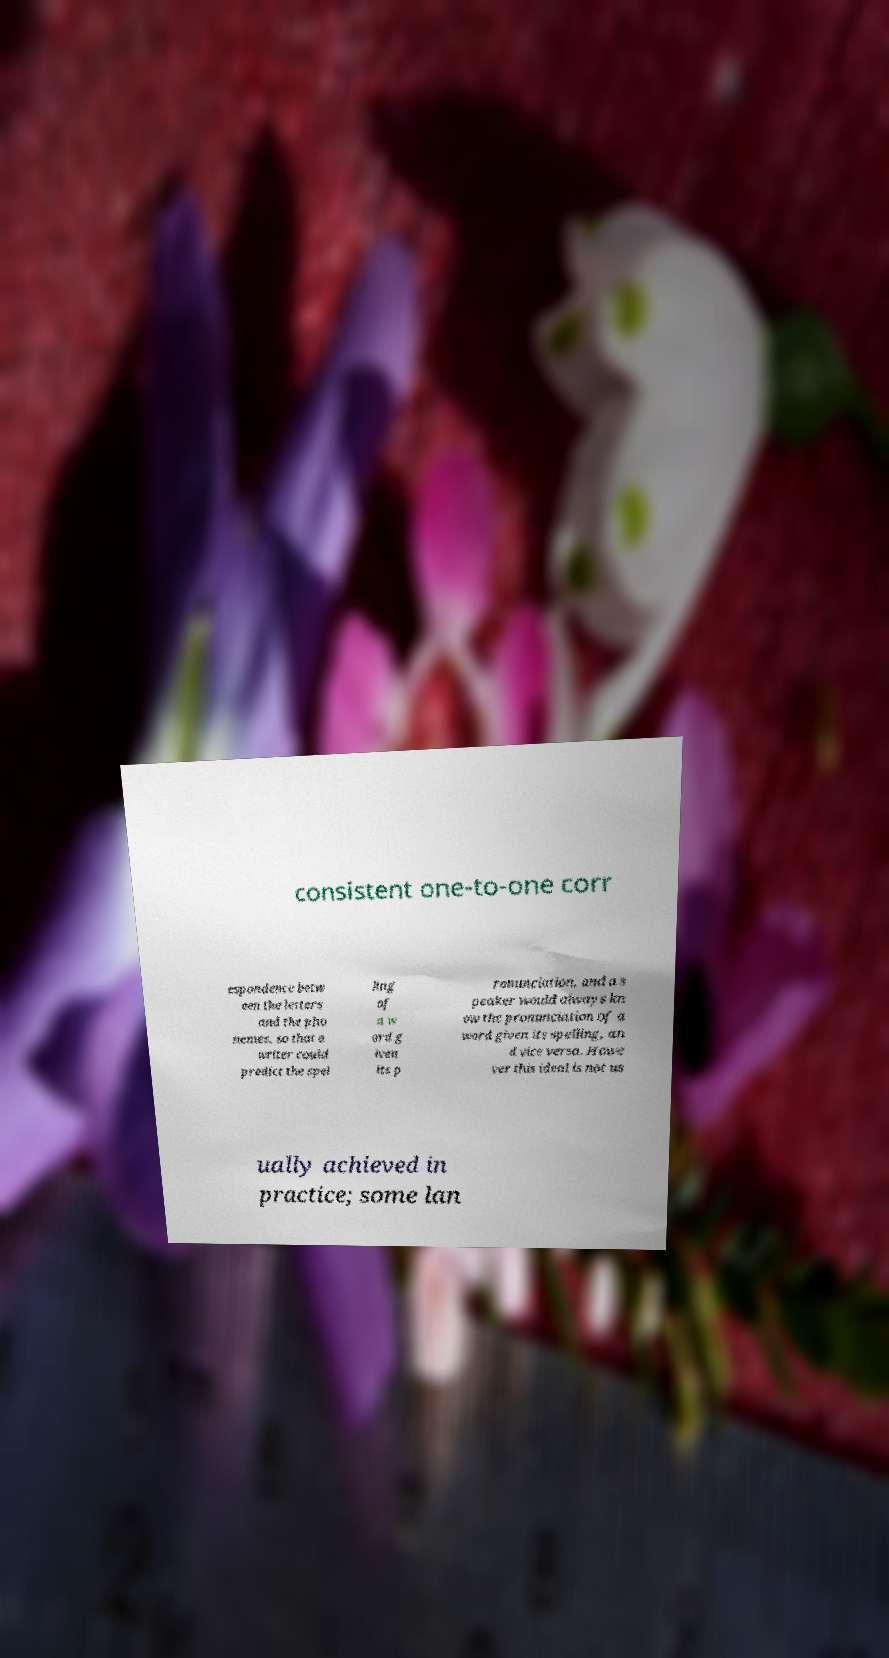Can you accurately transcribe the text from the provided image for me? consistent one-to-one corr espondence betw een the letters and the pho nemes, so that a writer could predict the spel ling of a w ord g iven its p ronunciation, and a s peaker would always kn ow the pronunciation of a word given its spelling, an d vice versa. Howe ver this ideal is not us ually achieved in practice; some lan 